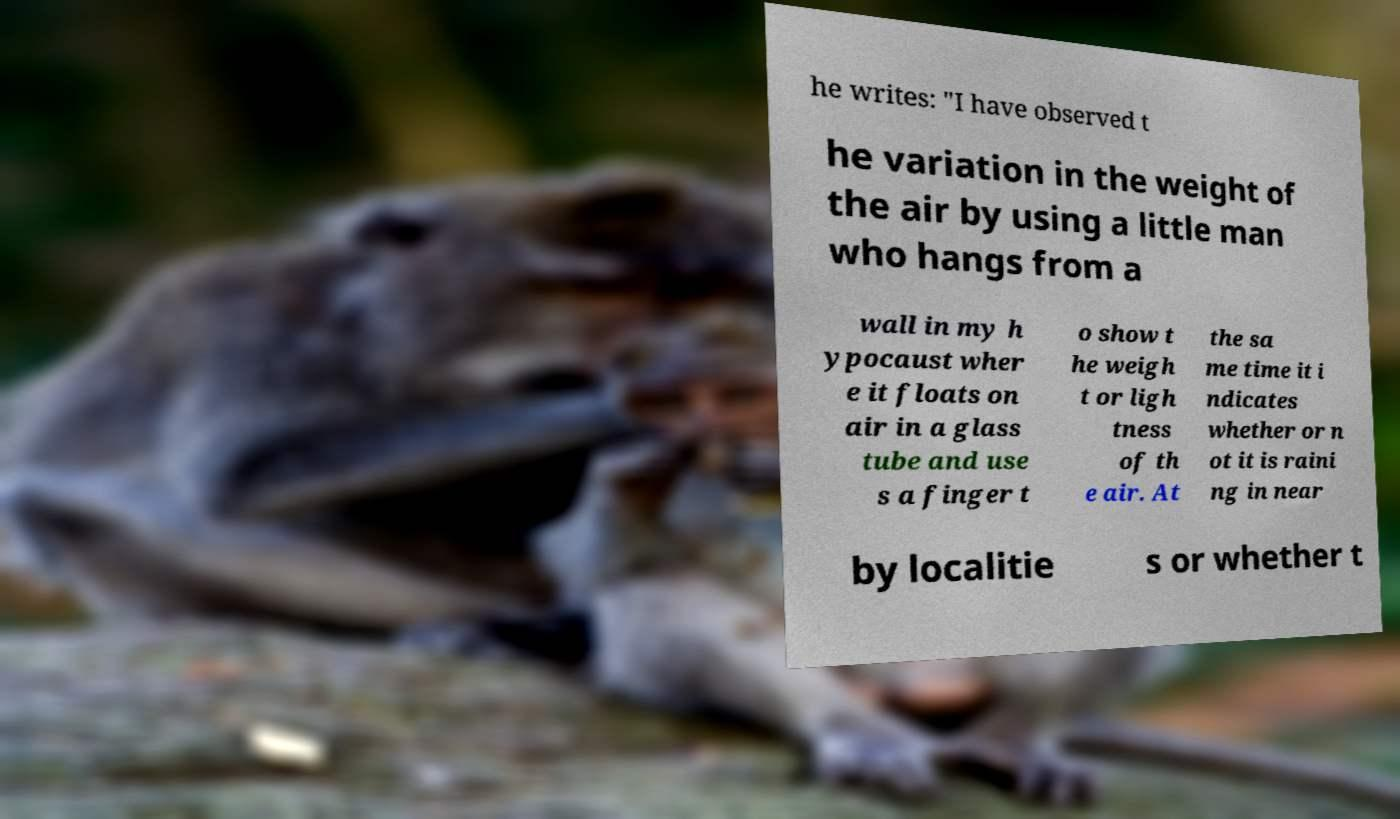Could you extract and type out the text from this image? he writes: "I have observed t he variation in the weight of the air by using a little man who hangs from a wall in my h ypocaust wher e it floats on air in a glass tube and use s a finger t o show t he weigh t or ligh tness of th e air. At the sa me time it i ndicates whether or n ot it is raini ng in near by localitie s or whether t 